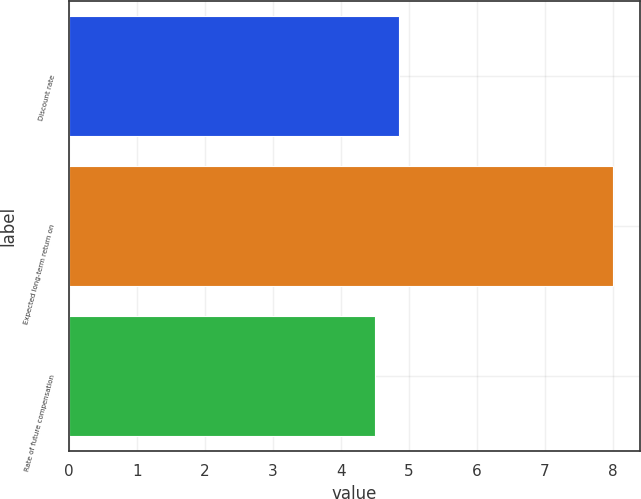Convert chart to OTSL. <chart><loc_0><loc_0><loc_500><loc_500><bar_chart><fcel>Discount rate<fcel>Expected long-term return on<fcel>Rate of future compensation<nl><fcel>4.85<fcel>8<fcel>4.5<nl></chart> 